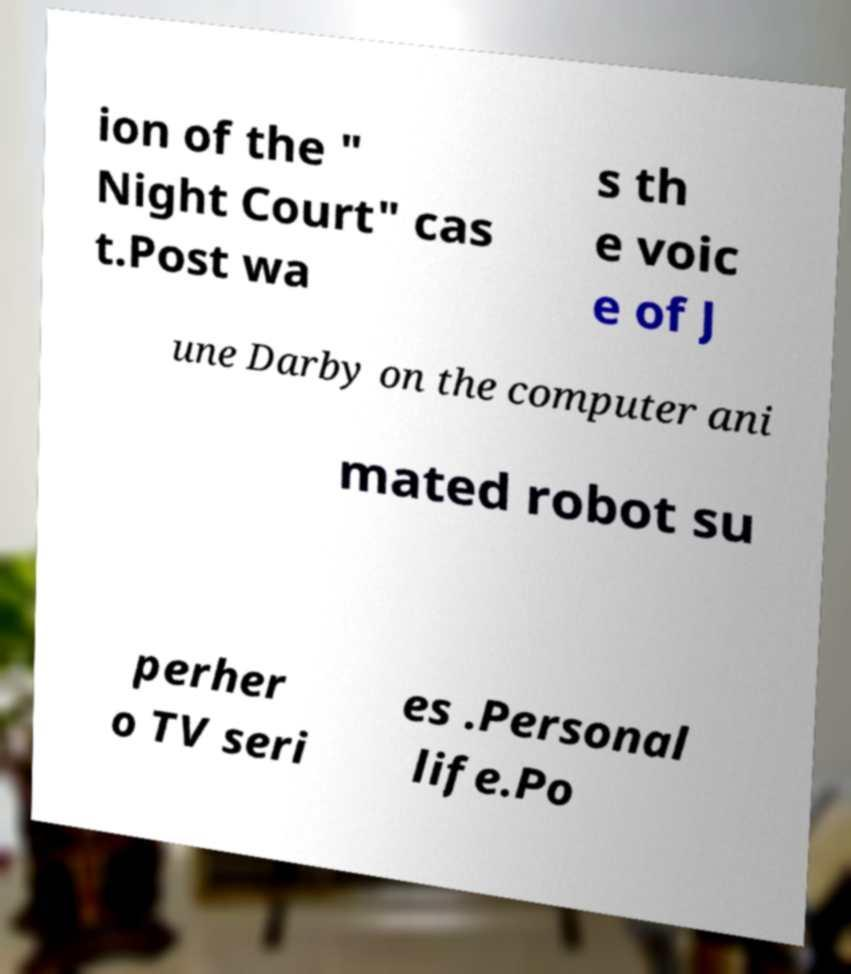Please identify and transcribe the text found in this image. ion of the " Night Court" cas t.Post wa s th e voic e of J une Darby on the computer ani mated robot su perher o TV seri es .Personal life.Po 